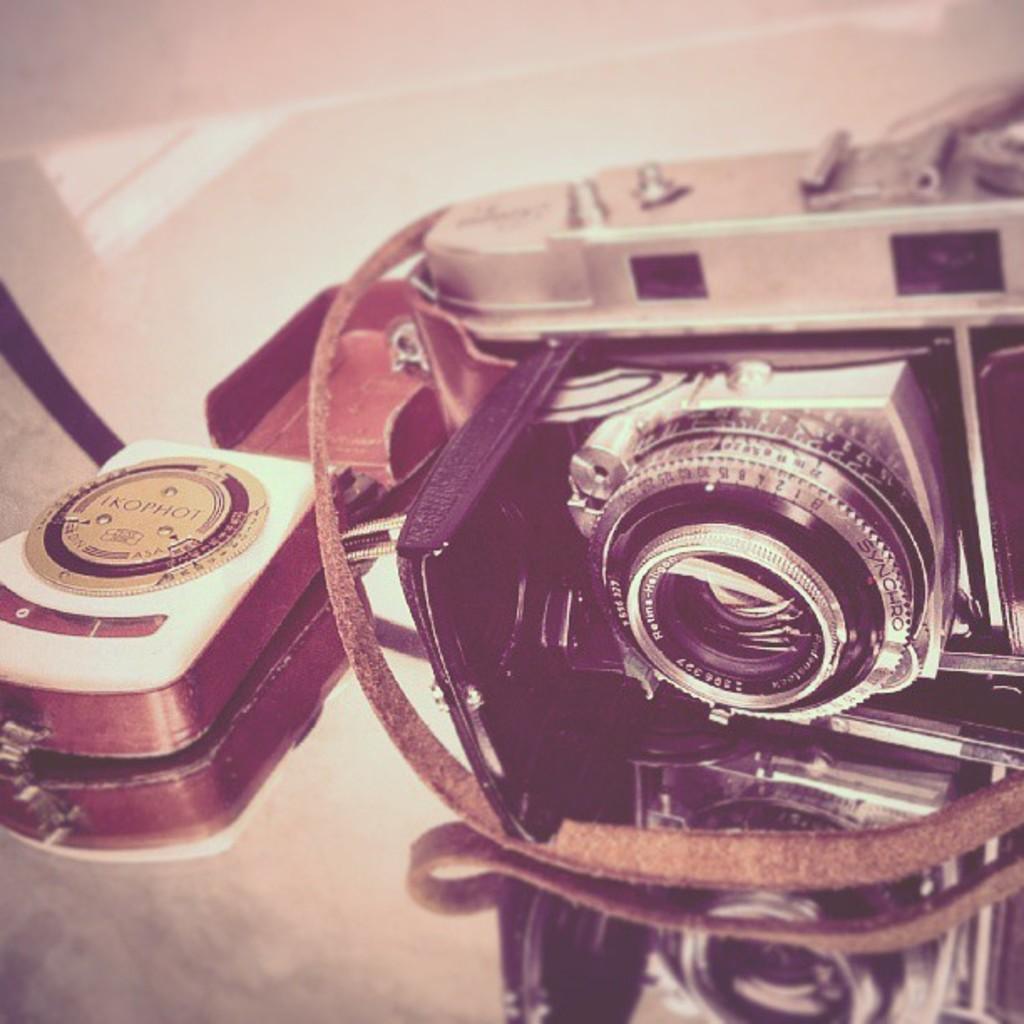In one or two sentences, can you explain what this image depicts? This picture is mainly highlighted with a camera placed on a glass surface and we can see the reflection. 